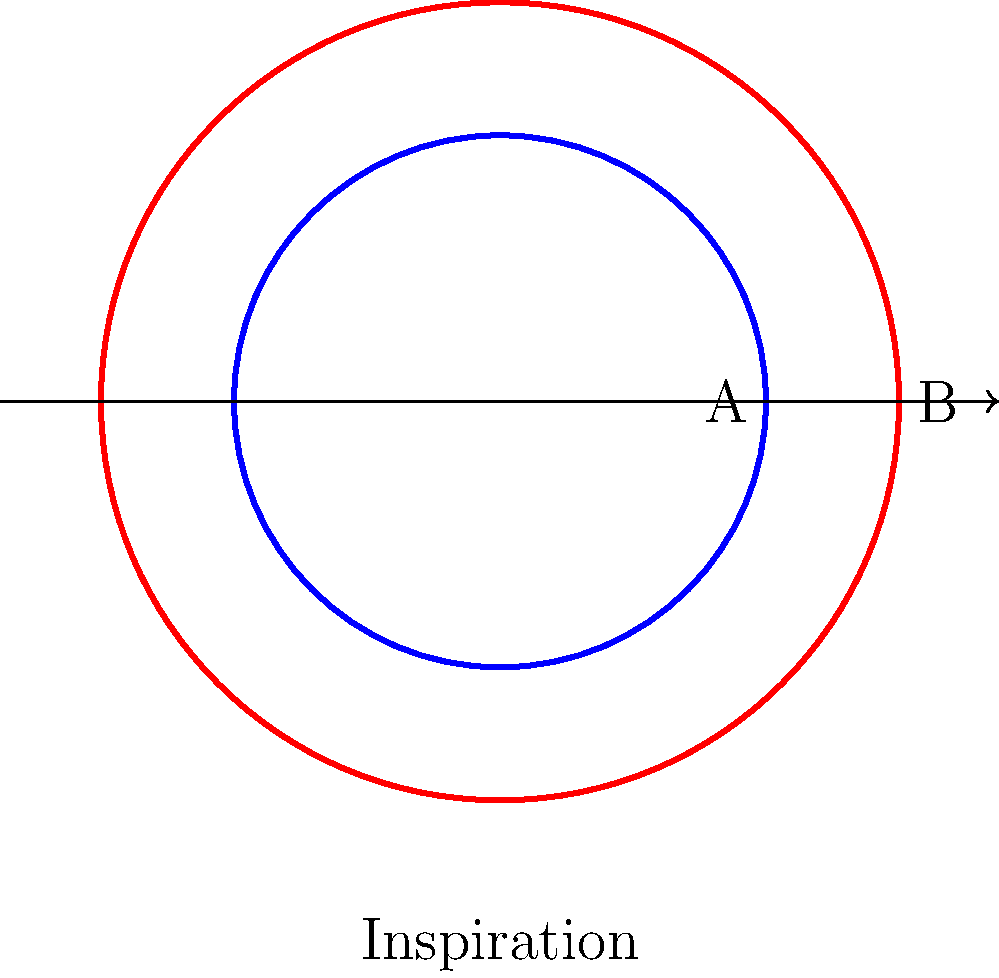In the diagram above, which topological property remains invariant during the transition from state A (blue) to state B (red) in lung alveoli during inspiration? To answer this question, let's consider the topological properties of the alveolus:

1. Shape: The overall shape changes from a smaller circle (A) to a larger circle (B). This is not a topological invariant.

2. Size: The size increases from A to B. Size is not a topological property, as it changes under continuous deformation.

3. Dimensionality: Both A and B are two-dimensional objects. This remains unchanged, but it's not specific enough for our question.

4. Connectedness: Both A and B are single, connected objects. This property is preserved.

5. Genus (number of holes): Both A and B have no holes (genus 0). This topological property remains invariant.

6. Euler characteristic: For a simple closed curve like A and B, the Euler characteristic is always 0 ($\chi = V - E + F = 0$, where $V$, $E$, and $F$ are the numbers of vertices, edges, and faces respectively). This remains constant.

Among these properties, the genus (or equivalently, the Euler characteristic) is the most specific topological invariant that remains unchanged during the alveolar expansion.
Answer: Genus (number of holes) 